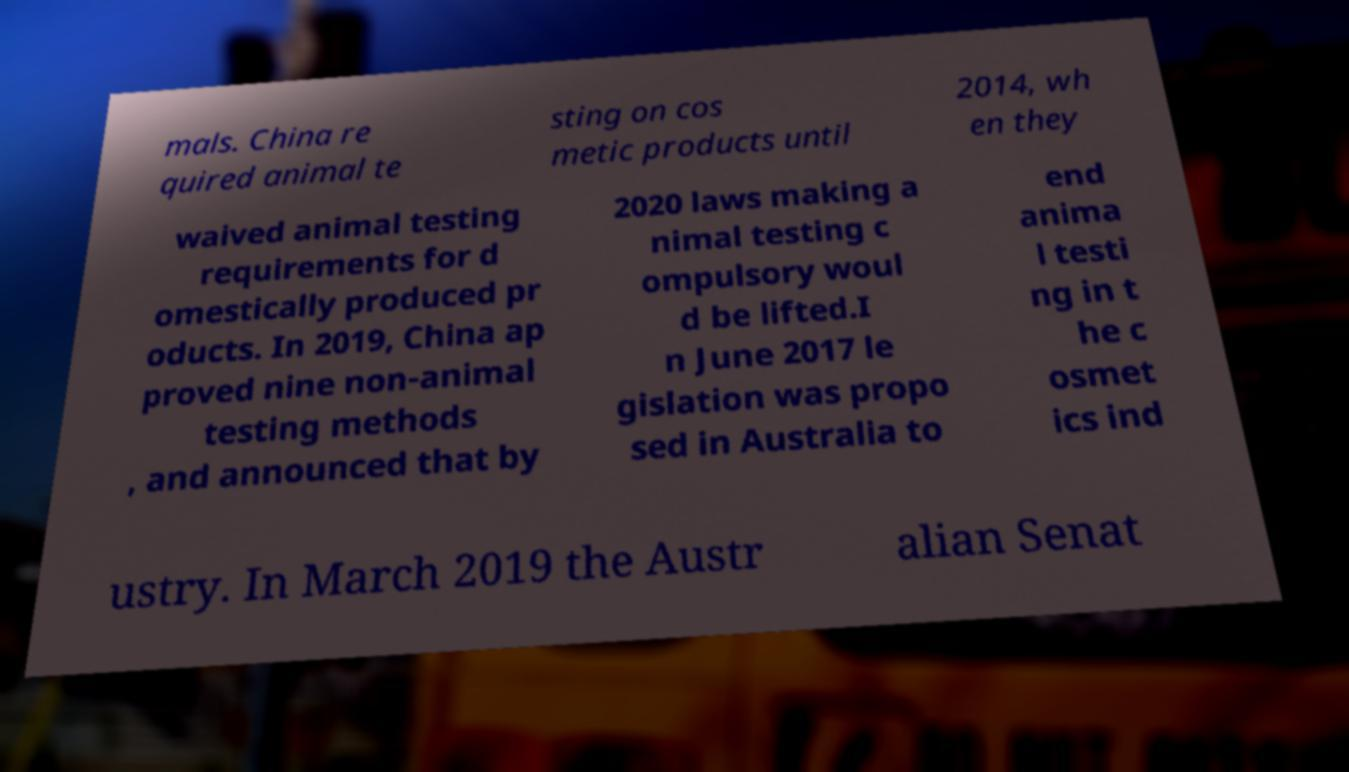Please identify and transcribe the text found in this image. mals. China re quired animal te sting on cos metic products until 2014, wh en they waived animal testing requirements for d omestically produced pr oducts. In 2019, China ap proved nine non-animal testing methods , and announced that by 2020 laws making a nimal testing c ompulsory woul d be lifted.I n June 2017 le gislation was propo sed in Australia to end anima l testi ng in t he c osmet ics ind ustry. In March 2019 the Austr alian Senat 